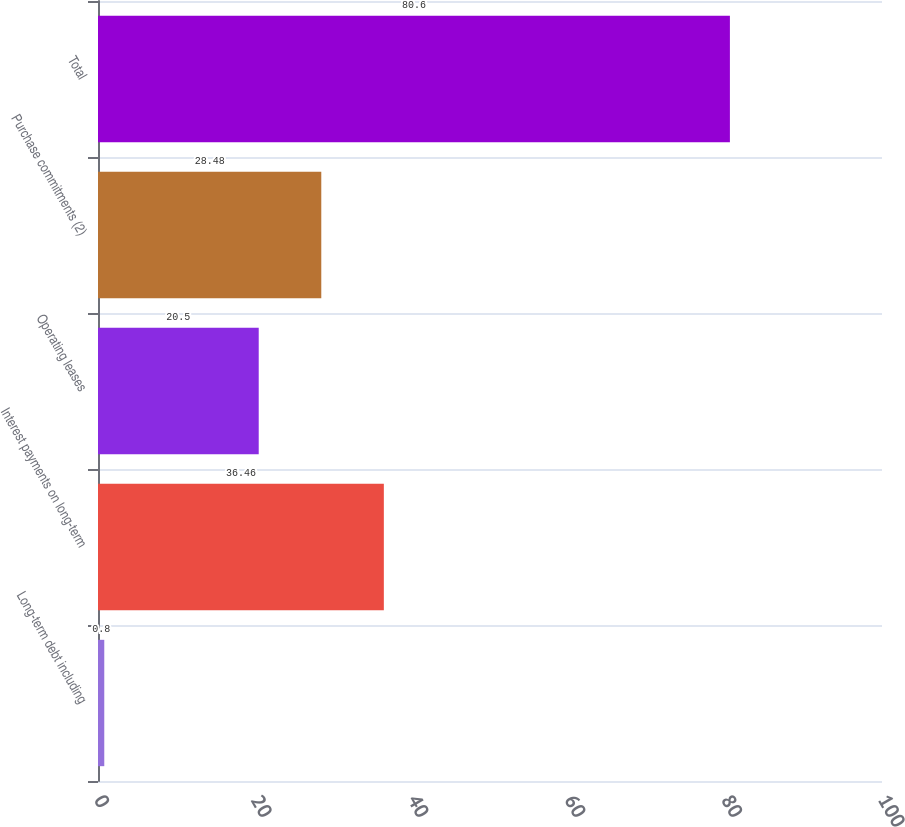Convert chart. <chart><loc_0><loc_0><loc_500><loc_500><bar_chart><fcel>Long-term debt including<fcel>Interest payments on long-term<fcel>Operating leases<fcel>Purchase commitments (2)<fcel>Total<nl><fcel>0.8<fcel>36.46<fcel>20.5<fcel>28.48<fcel>80.6<nl></chart> 